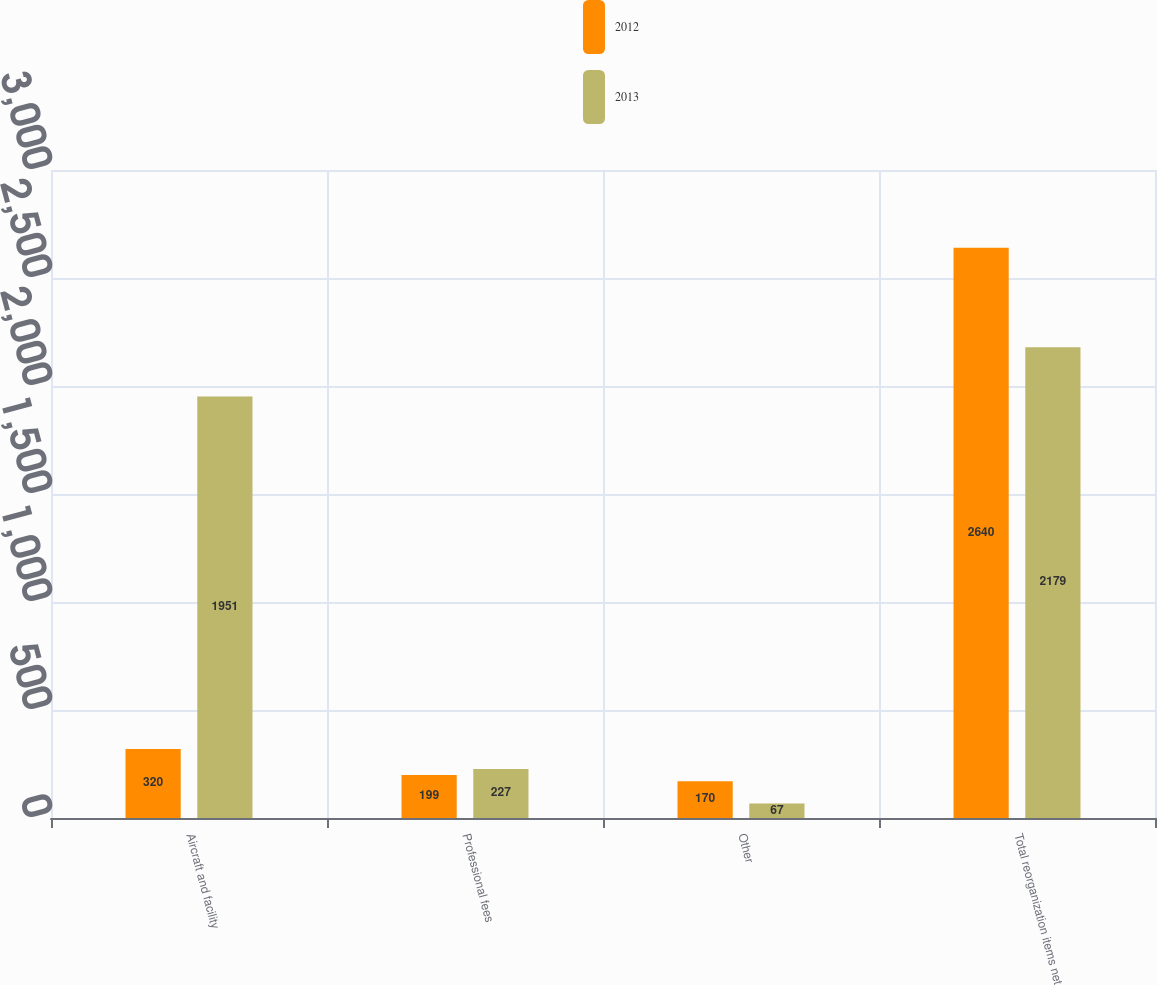Convert chart. <chart><loc_0><loc_0><loc_500><loc_500><stacked_bar_chart><ecel><fcel>Aircraft and facility<fcel>Professional fees<fcel>Other<fcel>Total reorganization items net<nl><fcel>2012<fcel>320<fcel>199<fcel>170<fcel>2640<nl><fcel>2013<fcel>1951<fcel>227<fcel>67<fcel>2179<nl></chart> 